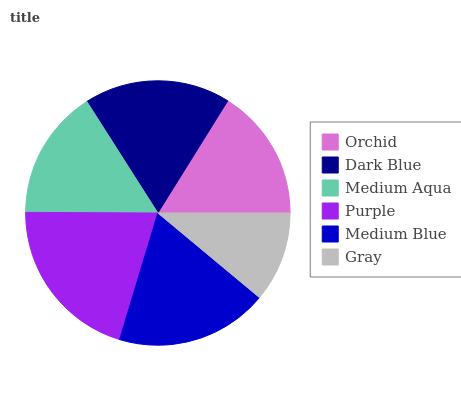Is Gray the minimum?
Answer yes or no. Yes. Is Purple the maximum?
Answer yes or no. Yes. Is Dark Blue the minimum?
Answer yes or no. No. Is Dark Blue the maximum?
Answer yes or no. No. Is Dark Blue greater than Orchid?
Answer yes or no. Yes. Is Orchid less than Dark Blue?
Answer yes or no. Yes. Is Orchid greater than Dark Blue?
Answer yes or no. No. Is Dark Blue less than Orchid?
Answer yes or no. No. Is Dark Blue the high median?
Answer yes or no. Yes. Is Orchid the low median?
Answer yes or no. Yes. Is Medium Blue the high median?
Answer yes or no. No. Is Dark Blue the low median?
Answer yes or no. No. 